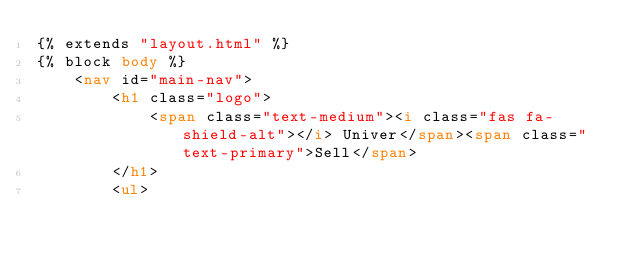Convert code to text. <code><loc_0><loc_0><loc_500><loc_500><_HTML_>{% extends "layout.html" %}
{% block body %}
    <nav id="main-nav">
        <h1 class="logo">
            <span class="text-medium"><i class="fas fa-shield-alt"></i> Univer</span><span class="text-primary">Sell</span>
        </h1>
        <ul></code> 